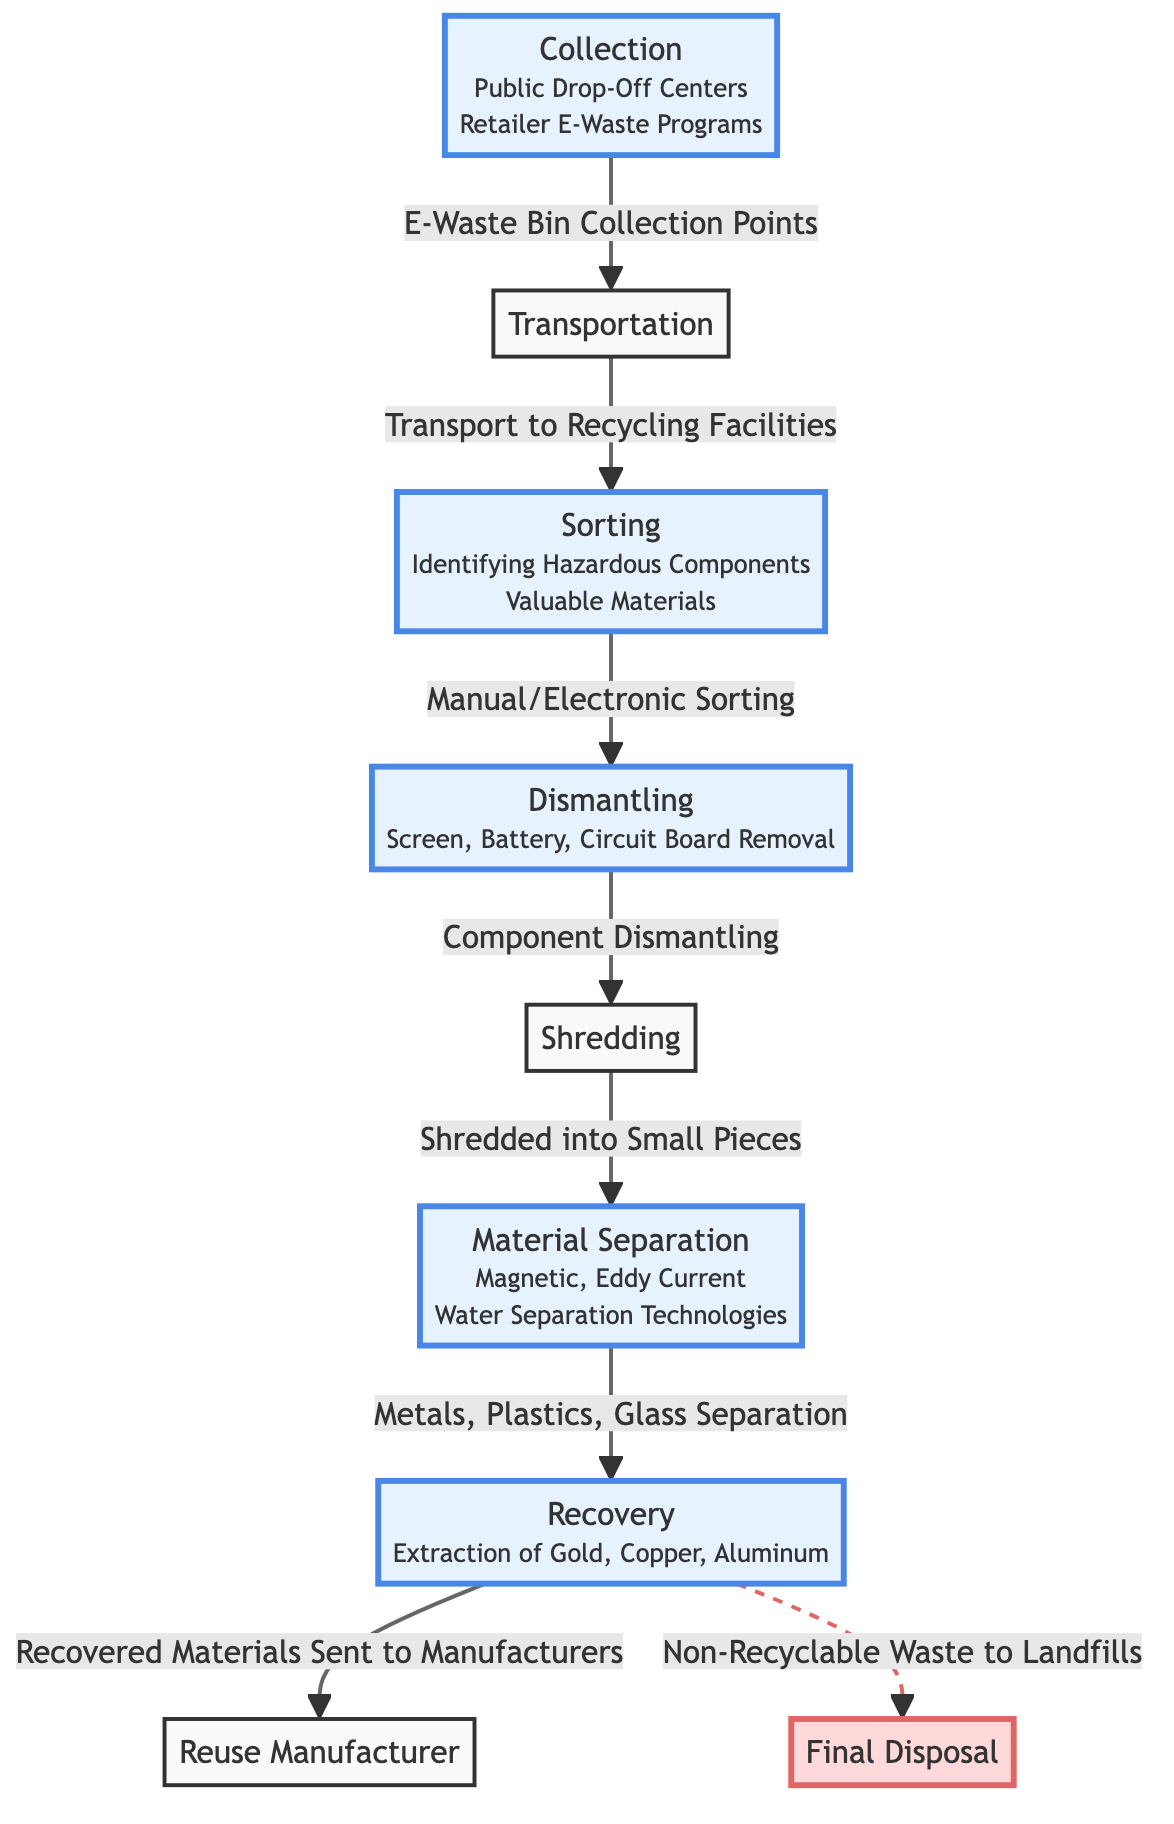What is the first step in the lifecycle of electronic waste? The diagram shows that the first step is "Collection," which includes public drop-off centers and retailer e-waste programs.
Answer: Collection How many steps are there in the recycling process of electronic waste? By counting the nodes in the diagram, there are a total of nine steps outlined in the process.
Answer: 9 What happens after transportation? The next step after transportation, as indicated in the diagram, is "Sorting," where hazardous components and valuable materials are identified.
Answer: Sorting What is extracted during the recovery stage? The recovery stage focuses on the extraction of specific valuable materials, identified as gold, copper, and aluminum in the diagram.
Answer: Gold, Copper, Aluminum Which step involves the removal of screens, batteries, and circuit boards? The step that involves the removal of screens, batteries, and circuit boards is "Dismantling," as shown in the diagram.
Answer: Dismantling What flows to the final disposal? The diagram shows that non-recyclable waste flows to "Final Disposal," indicating that this waste is sent to landfills.
Answer: Non-Recyclable Waste What types of separation methods are used in the material separation step? The diagram indicates that "Magnetic, Eddy Current, Water Separation Technologies" are used during the material separation step.
Answer: Magnetic, Eddy Current, Water Separation Technologies Which node is connected to "Reuse Manufacturer"? The node directly connected to "Reuse Manufacturer" is "Recovery," indicating that the recovered materials are sent to manufacturers for reuse.
Answer: Recovery Which part of the process is emphasized as dangerous? The "Final Disposal" part of the process is emphasized as dangerous, denoted by the red color and warning indicator in the diagram.
Answer: Final Disposal 